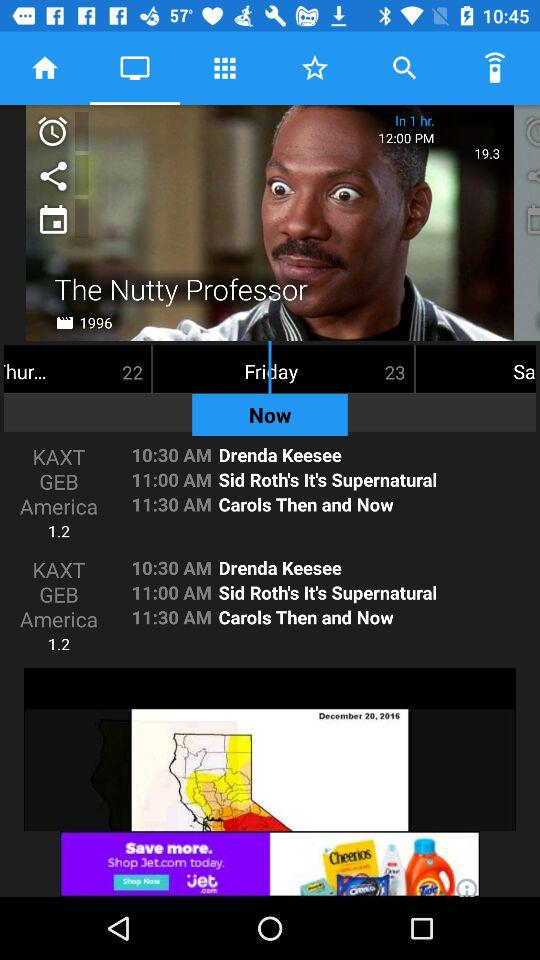At what channel Carols Then and Now telecast?
When the provided information is insufficient, respond with <no answer>. <no answer> 